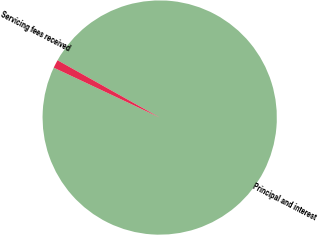Convert chart. <chart><loc_0><loc_0><loc_500><loc_500><pie_chart><fcel>Principal and interest<fcel>Servicing fees received<nl><fcel>98.87%<fcel>1.13%<nl></chart> 